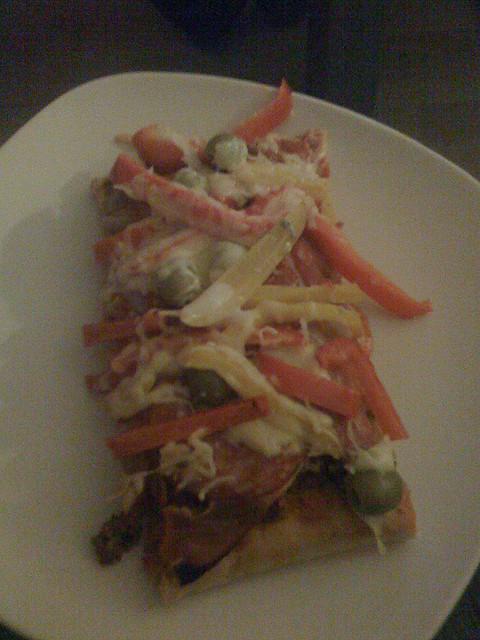The toppings are primarily from what food group?
Pick the correct solution from the four options below to address the question.
Options: Meat, fruit, vegetable, grain. Vegetable. 